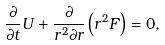<formula> <loc_0><loc_0><loc_500><loc_500>\frac { \partial } { \partial t } U + \frac { \partial } { r ^ { 2 } \partial r } \left ( r ^ { 2 } F \right ) = 0 ,</formula> 